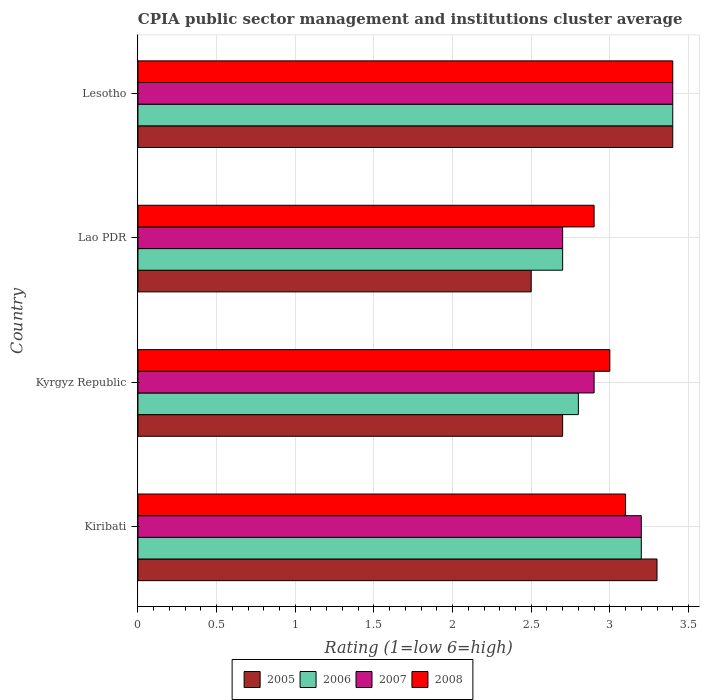What is the label of the 1st group of bars from the top?
Keep it short and to the point. Lesotho. In how many cases, is the number of bars for a given country not equal to the number of legend labels?
Offer a terse response. 0. In which country was the CPIA rating in 2006 maximum?
Your answer should be compact. Lesotho. In which country was the CPIA rating in 2008 minimum?
Give a very brief answer. Lao PDR. What is the total CPIA rating in 2008 in the graph?
Your response must be concise. 12.4. What is the difference between the CPIA rating in 2007 in Kiribati and that in Lesotho?
Your answer should be compact. -0.2. What is the difference between the CPIA rating in 2006 in Lao PDR and the CPIA rating in 2005 in Kiribati?
Provide a short and direct response. -0.6. What is the average CPIA rating in 2006 per country?
Keep it short and to the point. 3.02. What is the difference between the CPIA rating in 2005 and CPIA rating in 2008 in Kyrgyz Republic?
Make the answer very short. -0.3. In how many countries, is the CPIA rating in 2008 greater than 2.5 ?
Your response must be concise. 4. What is the ratio of the CPIA rating in 2008 in Kiribati to that in Lesotho?
Your answer should be compact. 0.91. Is the CPIA rating in 2006 in Kiribati less than that in Lao PDR?
Your answer should be very brief. No. What is the difference between the highest and the second highest CPIA rating in 2006?
Offer a very short reply. 0.2. Is the sum of the CPIA rating in 2005 in Kyrgyz Republic and Lesotho greater than the maximum CPIA rating in 2007 across all countries?
Provide a short and direct response. Yes. Is it the case that in every country, the sum of the CPIA rating in 2005 and CPIA rating in 2008 is greater than the sum of CPIA rating in 2007 and CPIA rating in 2006?
Offer a terse response. No. What does the 3rd bar from the top in Kiribati represents?
Provide a succinct answer. 2006. How many bars are there?
Your response must be concise. 16. How many countries are there in the graph?
Make the answer very short. 4. What is the difference between two consecutive major ticks on the X-axis?
Provide a short and direct response. 0.5. Are the values on the major ticks of X-axis written in scientific E-notation?
Give a very brief answer. No. Does the graph contain any zero values?
Give a very brief answer. No. Does the graph contain grids?
Make the answer very short. Yes. How are the legend labels stacked?
Provide a short and direct response. Horizontal. What is the title of the graph?
Your answer should be very brief. CPIA public sector management and institutions cluster average. Does "2012" appear as one of the legend labels in the graph?
Make the answer very short. No. What is the Rating (1=low 6=high) of 2005 in Kiribati?
Ensure brevity in your answer.  3.3. What is the Rating (1=low 6=high) of 2005 in Kyrgyz Republic?
Offer a very short reply. 2.7. What is the Rating (1=low 6=high) in 2006 in Kyrgyz Republic?
Your answer should be compact. 2.8. What is the Rating (1=low 6=high) of 2007 in Kyrgyz Republic?
Give a very brief answer. 2.9. What is the Rating (1=low 6=high) of 2008 in Kyrgyz Republic?
Provide a succinct answer. 3. What is the Rating (1=low 6=high) in 2005 in Lao PDR?
Provide a short and direct response. 2.5. What is the Rating (1=low 6=high) of 2008 in Lao PDR?
Your answer should be very brief. 2.9. What is the Rating (1=low 6=high) in 2005 in Lesotho?
Offer a very short reply. 3.4. What is the Rating (1=low 6=high) in 2006 in Lesotho?
Offer a terse response. 3.4. What is the Rating (1=low 6=high) in 2008 in Lesotho?
Give a very brief answer. 3.4. Across all countries, what is the maximum Rating (1=low 6=high) of 2006?
Ensure brevity in your answer.  3.4. Across all countries, what is the minimum Rating (1=low 6=high) of 2005?
Give a very brief answer. 2.5. Across all countries, what is the minimum Rating (1=low 6=high) in 2006?
Your answer should be compact. 2.7. Across all countries, what is the minimum Rating (1=low 6=high) of 2007?
Offer a very short reply. 2.7. Across all countries, what is the minimum Rating (1=low 6=high) of 2008?
Offer a terse response. 2.9. What is the difference between the Rating (1=low 6=high) of 2006 in Kiribati and that in Kyrgyz Republic?
Offer a very short reply. 0.4. What is the difference between the Rating (1=low 6=high) in 2007 in Kiribati and that in Lao PDR?
Provide a succinct answer. 0.5. What is the difference between the Rating (1=low 6=high) of 2007 in Kiribati and that in Lesotho?
Give a very brief answer. -0.2. What is the difference between the Rating (1=low 6=high) in 2008 in Kiribati and that in Lesotho?
Provide a short and direct response. -0.3. What is the difference between the Rating (1=low 6=high) in 2006 in Kyrgyz Republic and that in Lao PDR?
Your response must be concise. 0.1. What is the difference between the Rating (1=low 6=high) of 2007 in Kyrgyz Republic and that in Lao PDR?
Provide a succinct answer. 0.2. What is the difference between the Rating (1=low 6=high) in 2008 in Kyrgyz Republic and that in Lao PDR?
Offer a terse response. 0.1. What is the difference between the Rating (1=low 6=high) in 2005 in Kyrgyz Republic and that in Lesotho?
Provide a succinct answer. -0.7. What is the difference between the Rating (1=low 6=high) of 2006 in Kyrgyz Republic and that in Lesotho?
Ensure brevity in your answer.  -0.6. What is the difference between the Rating (1=low 6=high) in 2007 in Kyrgyz Republic and that in Lesotho?
Your response must be concise. -0.5. What is the difference between the Rating (1=low 6=high) of 2008 in Kyrgyz Republic and that in Lesotho?
Offer a very short reply. -0.4. What is the difference between the Rating (1=low 6=high) in 2006 in Lao PDR and that in Lesotho?
Your answer should be compact. -0.7. What is the difference between the Rating (1=low 6=high) of 2007 in Lao PDR and that in Lesotho?
Make the answer very short. -0.7. What is the difference between the Rating (1=low 6=high) in 2005 in Kiribati and the Rating (1=low 6=high) in 2006 in Kyrgyz Republic?
Provide a short and direct response. 0.5. What is the difference between the Rating (1=low 6=high) in 2005 in Kiribati and the Rating (1=low 6=high) in 2007 in Kyrgyz Republic?
Your answer should be very brief. 0.4. What is the difference between the Rating (1=low 6=high) in 2005 in Kiribati and the Rating (1=low 6=high) in 2006 in Lao PDR?
Provide a succinct answer. 0.6. What is the difference between the Rating (1=low 6=high) of 2006 in Kiribati and the Rating (1=low 6=high) of 2008 in Lao PDR?
Give a very brief answer. 0.3. What is the difference between the Rating (1=low 6=high) in 2007 in Kiribati and the Rating (1=low 6=high) in 2008 in Lao PDR?
Give a very brief answer. 0.3. What is the difference between the Rating (1=low 6=high) of 2005 in Kiribati and the Rating (1=low 6=high) of 2006 in Lesotho?
Your answer should be very brief. -0.1. What is the difference between the Rating (1=low 6=high) of 2005 in Kiribati and the Rating (1=low 6=high) of 2007 in Lesotho?
Offer a very short reply. -0.1. What is the difference between the Rating (1=low 6=high) of 2006 in Kiribati and the Rating (1=low 6=high) of 2007 in Lesotho?
Make the answer very short. -0.2. What is the difference between the Rating (1=low 6=high) in 2007 in Kiribati and the Rating (1=low 6=high) in 2008 in Lesotho?
Keep it short and to the point. -0.2. What is the difference between the Rating (1=low 6=high) in 2005 in Kyrgyz Republic and the Rating (1=low 6=high) in 2006 in Lao PDR?
Provide a short and direct response. 0. What is the difference between the Rating (1=low 6=high) of 2005 in Kyrgyz Republic and the Rating (1=low 6=high) of 2008 in Lao PDR?
Provide a succinct answer. -0.2. What is the difference between the Rating (1=low 6=high) of 2006 in Kyrgyz Republic and the Rating (1=low 6=high) of 2007 in Lao PDR?
Your answer should be very brief. 0.1. What is the difference between the Rating (1=low 6=high) of 2006 in Kyrgyz Republic and the Rating (1=low 6=high) of 2008 in Lao PDR?
Your response must be concise. -0.1. What is the difference between the Rating (1=low 6=high) of 2007 in Kyrgyz Republic and the Rating (1=low 6=high) of 2008 in Lao PDR?
Give a very brief answer. 0. What is the difference between the Rating (1=low 6=high) of 2006 in Kyrgyz Republic and the Rating (1=low 6=high) of 2007 in Lesotho?
Give a very brief answer. -0.6. What is the difference between the Rating (1=low 6=high) in 2005 in Lao PDR and the Rating (1=low 6=high) in 2008 in Lesotho?
Offer a very short reply. -0.9. What is the difference between the Rating (1=low 6=high) in 2007 in Lao PDR and the Rating (1=low 6=high) in 2008 in Lesotho?
Give a very brief answer. -0.7. What is the average Rating (1=low 6=high) of 2005 per country?
Keep it short and to the point. 2.98. What is the average Rating (1=low 6=high) in 2006 per country?
Your answer should be compact. 3.02. What is the average Rating (1=low 6=high) in 2007 per country?
Offer a terse response. 3.05. What is the average Rating (1=low 6=high) of 2008 per country?
Make the answer very short. 3.1. What is the difference between the Rating (1=low 6=high) of 2005 and Rating (1=low 6=high) of 2006 in Kiribati?
Provide a succinct answer. 0.1. What is the difference between the Rating (1=low 6=high) in 2005 and Rating (1=low 6=high) in 2007 in Kiribati?
Ensure brevity in your answer.  0.1. What is the difference between the Rating (1=low 6=high) of 2005 and Rating (1=low 6=high) of 2008 in Kiribati?
Give a very brief answer. 0.2. What is the difference between the Rating (1=low 6=high) in 2007 and Rating (1=low 6=high) in 2008 in Kiribati?
Provide a succinct answer. 0.1. What is the difference between the Rating (1=low 6=high) of 2005 and Rating (1=low 6=high) of 2006 in Kyrgyz Republic?
Give a very brief answer. -0.1. What is the difference between the Rating (1=low 6=high) in 2005 and Rating (1=low 6=high) in 2008 in Kyrgyz Republic?
Your response must be concise. -0.3. What is the difference between the Rating (1=low 6=high) of 2006 and Rating (1=low 6=high) of 2008 in Kyrgyz Republic?
Make the answer very short. -0.2. What is the difference between the Rating (1=low 6=high) of 2005 and Rating (1=low 6=high) of 2007 in Lao PDR?
Offer a very short reply. -0.2. What is the difference between the Rating (1=low 6=high) of 2005 and Rating (1=low 6=high) of 2008 in Lao PDR?
Your answer should be very brief. -0.4. What is the difference between the Rating (1=low 6=high) in 2005 and Rating (1=low 6=high) in 2006 in Lesotho?
Your answer should be compact. 0. What is the difference between the Rating (1=low 6=high) in 2006 and Rating (1=low 6=high) in 2007 in Lesotho?
Provide a succinct answer. 0. What is the difference between the Rating (1=low 6=high) in 2006 and Rating (1=low 6=high) in 2008 in Lesotho?
Offer a terse response. 0. What is the ratio of the Rating (1=low 6=high) of 2005 in Kiribati to that in Kyrgyz Republic?
Ensure brevity in your answer.  1.22. What is the ratio of the Rating (1=low 6=high) in 2006 in Kiribati to that in Kyrgyz Republic?
Offer a very short reply. 1.14. What is the ratio of the Rating (1=low 6=high) in 2007 in Kiribati to that in Kyrgyz Republic?
Ensure brevity in your answer.  1.1. What is the ratio of the Rating (1=low 6=high) of 2005 in Kiribati to that in Lao PDR?
Keep it short and to the point. 1.32. What is the ratio of the Rating (1=low 6=high) of 2006 in Kiribati to that in Lao PDR?
Offer a terse response. 1.19. What is the ratio of the Rating (1=low 6=high) of 2007 in Kiribati to that in Lao PDR?
Offer a terse response. 1.19. What is the ratio of the Rating (1=low 6=high) of 2008 in Kiribati to that in Lao PDR?
Make the answer very short. 1.07. What is the ratio of the Rating (1=low 6=high) in 2005 in Kiribati to that in Lesotho?
Provide a short and direct response. 0.97. What is the ratio of the Rating (1=low 6=high) of 2008 in Kiribati to that in Lesotho?
Provide a short and direct response. 0.91. What is the ratio of the Rating (1=low 6=high) in 2007 in Kyrgyz Republic to that in Lao PDR?
Your response must be concise. 1.07. What is the ratio of the Rating (1=low 6=high) of 2008 in Kyrgyz Republic to that in Lao PDR?
Provide a succinct answer. 1.03. What is the ratio of the Rating (1=low 6=high) of 2005 in Kyrgyz Republic to that in Lesotho?
Keep it short and to the point. 0.79. What is the ratio of the Rating (1=low 6=high) of 2006 in Kyrgyz Republic to that in Lesotho?
Provide a succinct answer. 0.82. What is the ratio of the Rating (1=low 6=high) of 2007 in Kyrgyz Republic to that in Lesotho?
Offer a very short reply. 0.85. What is the ratio of the Rating (1=low 6=high) of 2008 in Kyrgyz Republic to that in Lesotho?
Ensure brevity in your answer.  0.88. What is the ratio of the Rating (1=low 6=high) in 2005 in Lao PDR to that in Lesotho?
Give a very brief answer. 0.74. What is the ratio of the Rating (1=low 6=high) of 2006 in Lao PDR to that in Lesotho?
Your response must be concise. 0.79. What is the ratio of the Rating (1=low 6=high) in 2007 in Lao PDR to that in Lesotho?
Your response must be concise. 0.79. What is the ratio of the Rating (1=low 6=high) of 2008 in Lao PDR to that in Lesotho?
Give a very brief answer. 0.85. What is the difference between the highest and the second highest Rating (1=low 6=high) of 2007?
Provide a succinct answer. 0.2. What is the difference between the highest and the lowest Rating (1=low 6=high) of 2006?
Give a very brief answer. 0.7. What is the difference between the highest and the lowest Rating (1=low 6=high) of 2008?
Give a very brief answer. 0.5. 